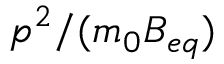Convert formula to latex. <formula><loc_0><loc_0><loc_500><loc_500>p ^ { 2 } / ( m _ { 0 } B _ { e q } )</formula> 